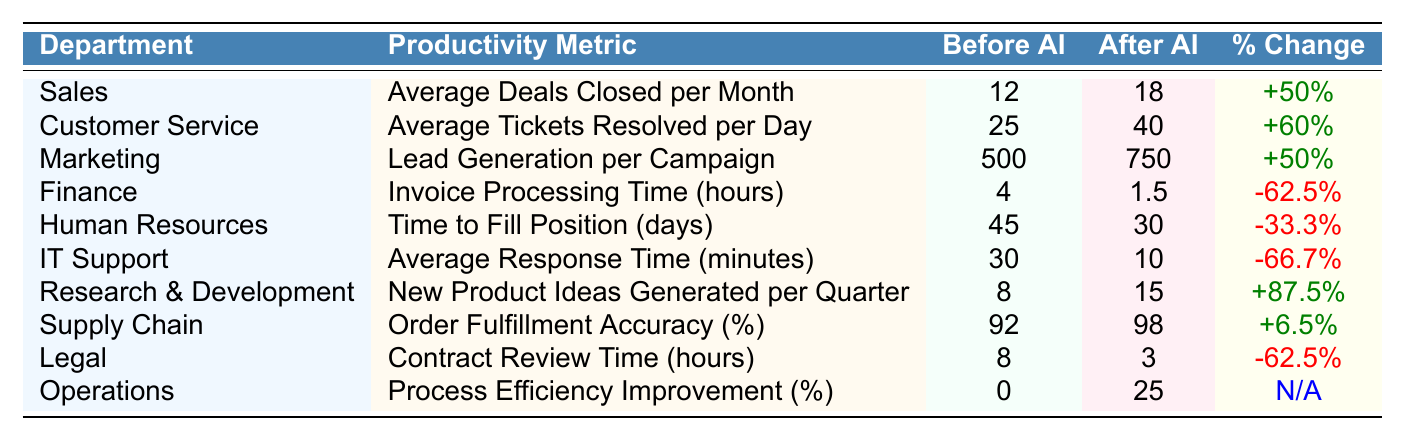What is the productivity metric for the Sales department after AI integration? The table shows that the Sales department's average deals closed per month after AI integration is 18.
Answer: 18 What was the average tickets resolved per day in Customer Service before AI integration? According to the table, the average tickets resolved per day in Customer Service before AI integration was 25.
Answer: 25 Which department saw the highest percentage increase in productivity after AI integration? Reviewing the percentage change in each department, Research & Development had the highest percentage increase with +87.5%.
Answer: Research & Development Is the average response time in IT Support decreased after AI integration? The table indicates a decrease in the average response time in IT Support from 30 minutes to 10 minutes, confirming a decrease.
Answer: Yes What is the percentage change in invoice processing time for the Finance department? The table presents a decrease in invoice processing time for the Finance department, resulting in a percentage change of -62.5%.
Answer: -62.5% What is the average time to fill a position in Human Resources after AI integration? The table indicates that after AI integration, the average time to fill a position in Human Resources is 30 days.
Answer: 30 days How many more contracts can be reviewed by Legal after AI integration compared to before? The table shows a reduction in contract review time from 8 hours to 3 hours, leading to the conclusion that 5 hours more can be spent on other tasks after integrating AI.
Answer: 5 hours Which department's process efficiency improvement improved to 25% after AI integration? The Operations department experienced a process efficiency improvement to 25% after the integration of AI, as shown in the table.
Answer: Operations Compare the lead generation per campaign in Marketing before and after AI integration. Before AI integration, lead generation per campaign was 500, which increased to 750 after integration, indicating a positive change.
Answer: Increased from 500 to 750 What is the decrease in average response time in IT Support after AI integration? The average response time in IT Support decreased from 30 minutes to 10 minutes, showing a change of 20 minutes.
Answer: 20 minutes decrease 